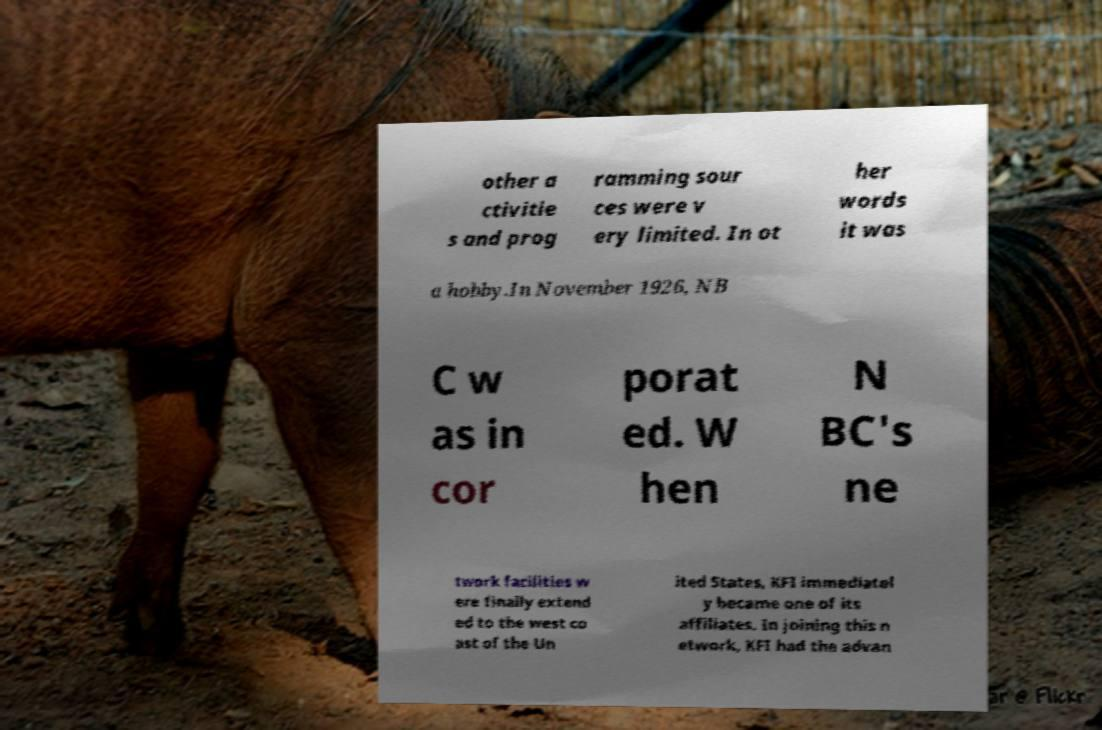There's text embedded in this image that I need extracted. Can you transcribe it verbatim? other a ctivitie s and prog ramming sour ces were v ery limited. In ot her words it was a hobby.In November 1926, NB C w as in cor porat ed. W hen N BC's ne twork facilities w ere finally extend ed to the west co ast of the Un ited States, KFI immediatel y became one of its affiliates. In joining this n etwork, KFI had the advan 